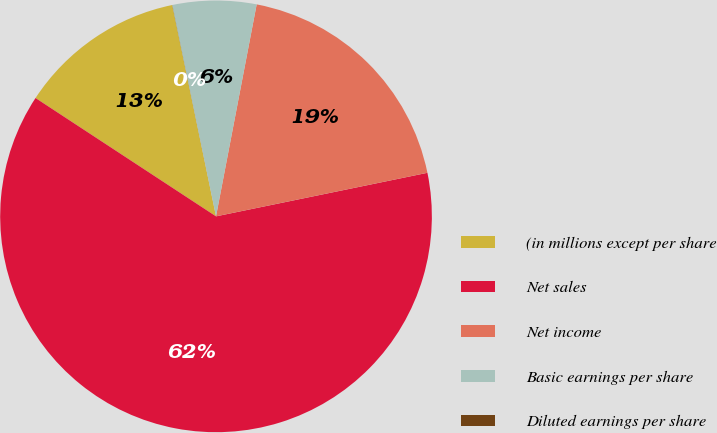Convert chart. <chart><loc_0><loc_0><loc_500><loc_500><pie_chart><fcel>(in millions except per share<fcel>Net sales<fcel>Net income<fcel>Basic earnings per share<fcel>Diluted earnings per share<nl><fcel>12.51%<fcel>62.47%<fcel>18.75%<fcel>6.26%<fcel>0.01%<nl></chart> 